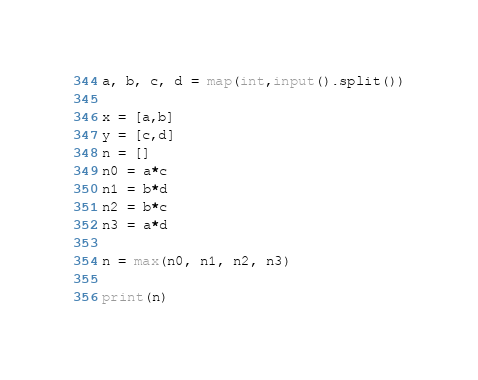<code> <loc_0><loc_0><loc_500><loc_500><_Python_>a, b, c, d = map(int,input().split())

x = [a,b]
y = [c,d]
n = []
n0 = a*c
n1 = b*d
n2 = b*c
n3 = a*d

n = max(n0, n1, n2, n3)

print(n)</code> 